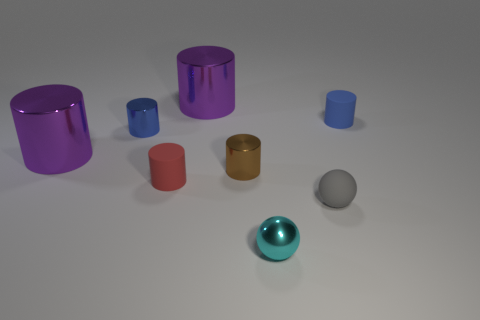The gray rubber object that is the same size as the red matte object is what shape?
Your answer should be compact. Sphere. There is a tiny thing that is in front of the small ball that is behind the small cyan sphere; what is its material?
Give a very brief answer. Metal. How many things are either purple metal cylinders that are to the left of the small red object or tiny gray spheres?
Provide a succinct answer. 2. The purple metallic thing that is behind the small matte cylinder that is right of the small cyan shiny sphere is what shape?
Your answer should be very brief. Cylinder. There is a red rubber object; is its size the same as the cylinder that is to the right of the small gray matte sphere?
Ensure brevity in your answer.  Yes. What is the purple cylinder that is in front of the tiny blue matte thing made of?
Provide a succinct answer. Metal. What number of tiny objects are in front of the red thing and left of the small red cylinder?
Provide a succinct answer. 0. There is another gray ball that is the same size as the shiny ball; what is its material?
Provide a succinct answer. Rubber. Is the size of the matte object behind the brown shiny cylinder the same as the purple object that is in front of the blue rubber cylinder?
Give a very brief answer. No. Are there any big cylinders right of the gray rubber ball?
Your answer should be compact. No. 